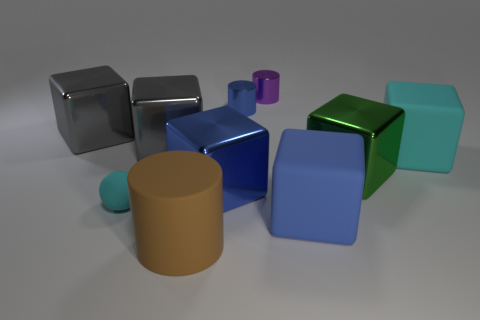The small thing that is in front of the small purple metal cylinder and behind the green thing has what shape?
Your answer should be very brief. Cylinder. What number of big objects are gray shiny objects or brown cylinders?
Give a very brief answer. 3. Are there the same number of big matte objects behind the big blue shiny cube and green metal cubes that are behind the green thing?
Your response must be concise. No. How many other objects are the same color as the tiny matte thing?
Ensure brevity in your answer.  1. Is the number of rubber things behind the brown cylinder the same as the number of big cyan rubber things?
Keep it short and to the point. No. Do the brown rubber thing and the blue shiny cube have the same size?
Provide a succinct answer. Yes. There is a thing that is in front of the small cyan matte sphere and behind the big rubber cylinder; what is its material?
Your answer should be very brief. Rubber. How many large blue rubber things are the same shape as the green thing?
Keep it short and to the point. 1. There is a cyan object that is to the right of the big green metallic thing; what is it made of?
Offer a very short reply. Rubber. Are there fewer blue rubber cubes to the left of the large brown matte cylinder than tiny cyan metal objects?
Give a very brief answer. No. 